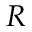<formula> <loc_0><loc_0><loc_500><loc_500>R</formula> 